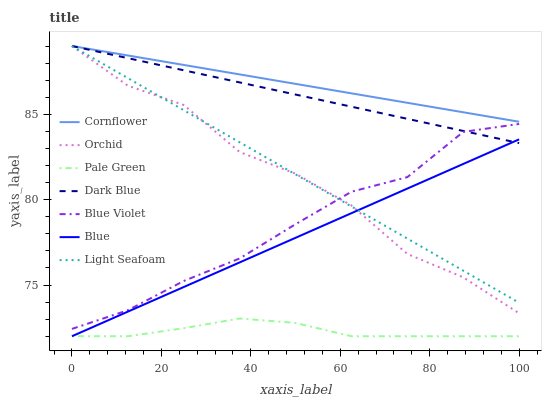Does Pale Green have the minimum area under the curve?
Answer yes or no. Yes. Does Cornflower have the maximum area under the curve?
Answer yes or no. Yes. Does Dark Blue have the minimum area under the curve?
Answer yes or no. No. Does Dark Blue have the maximum area under the curve?
Answer yes or no. No. Is Cornflower the smoothest?
Answer yes or no. Yes. Is Orchid the roughest?
Answer yes or no. Yes. Is Dark Blue the smoothest?
Answer yes or no. No. Is Dark Blue the roughest?
Answer yes or no. No. Does Dark Blue have the lowest value?
Answer yes or no. No. Does Pale Green have the highest value?
Answer yes or no. No. Is Pale Green less than Orchid?
Answer yes or no. Yes. Is Dark Blue greater than Pale Green?
Answer yes or no. Yes. Does Pale Green intersect Orchid?
Answer yes or no. No. 